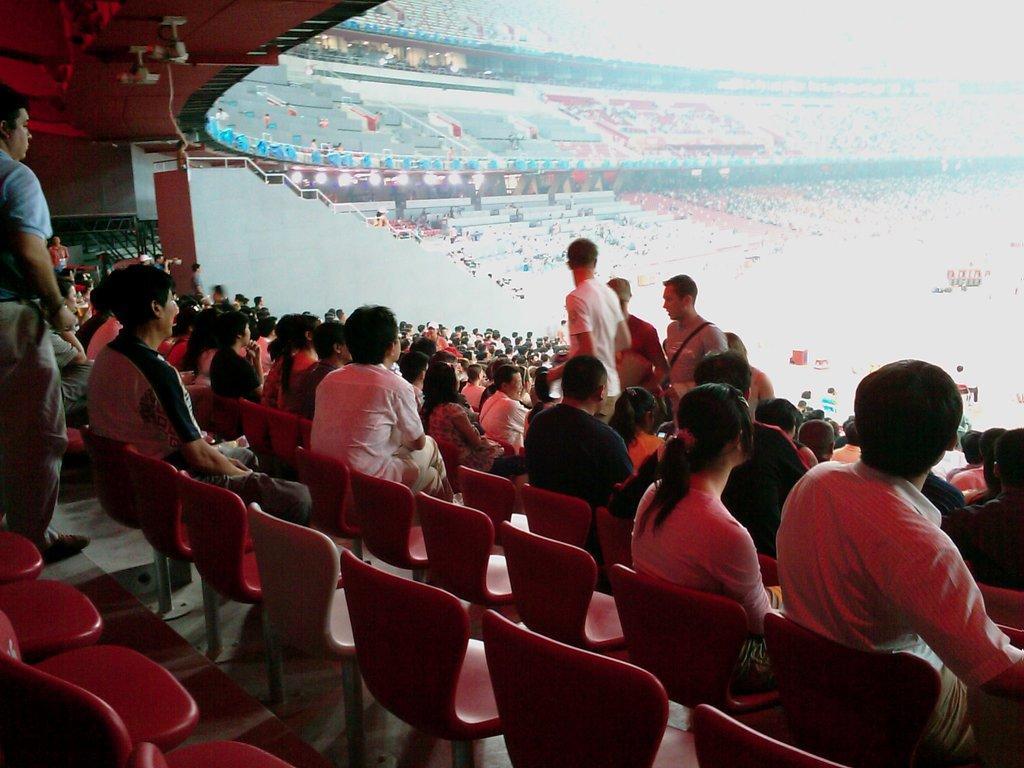Could you give a brief overview of what you see in this image? In this picture I can see group of people among them some are standing and some are sitting on chairs. In the background I can see the stadium. 